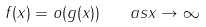Convert formula to latex. <formula><loc_0><loc_0><loc_500><loc_500>f ( x ) = o ( g ( x ) ) \quad a s x \to \infty</formula> 